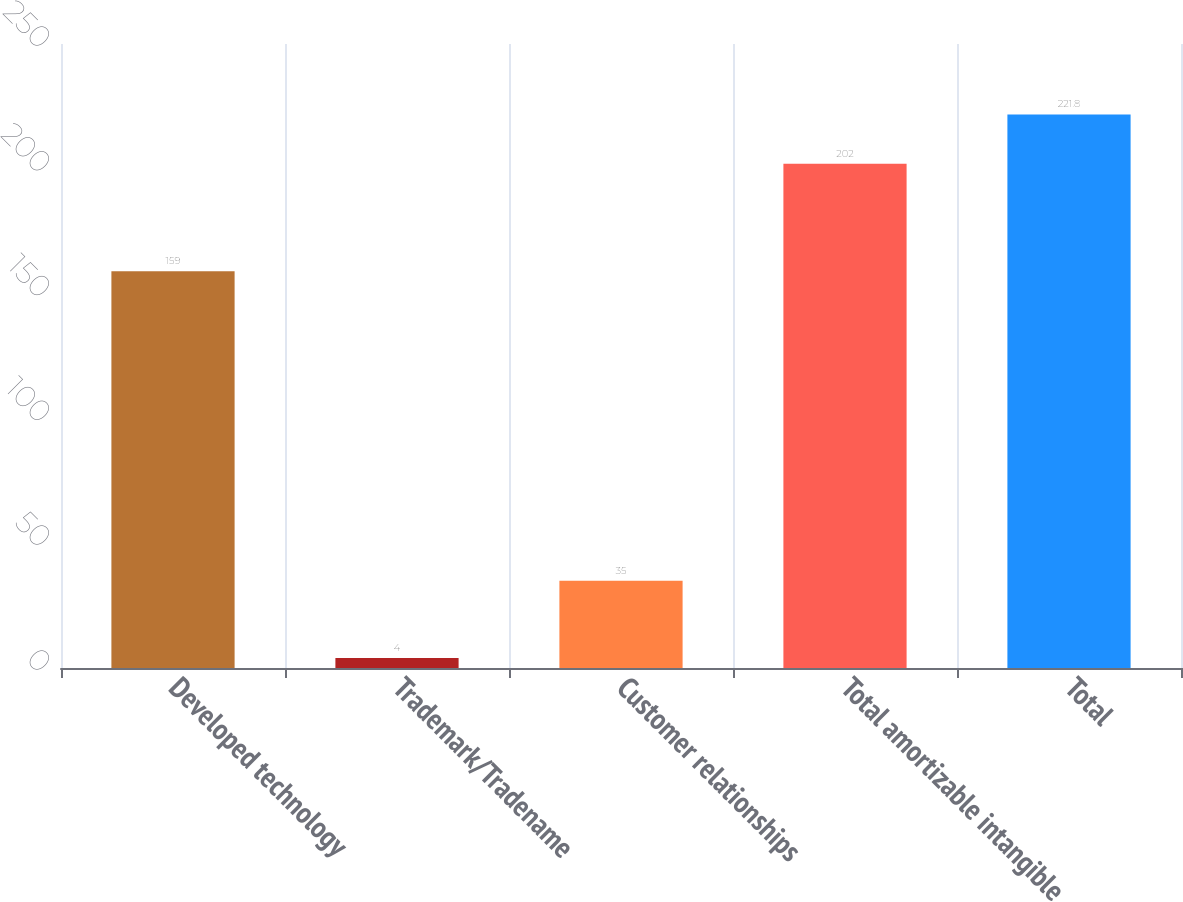Convert chart. <chart><loc_0><loc_0><loc_500><loc_500><bar_chart><fcel>Developed technology<fcel>Trademark/Tradename<fcel>Customer relationships<fcel>Total amortizable intangible<fcel>Total<nl><fcel>159<fcel>4<fcel>35<fcel>202<fcel>221.8<nl></chart> 